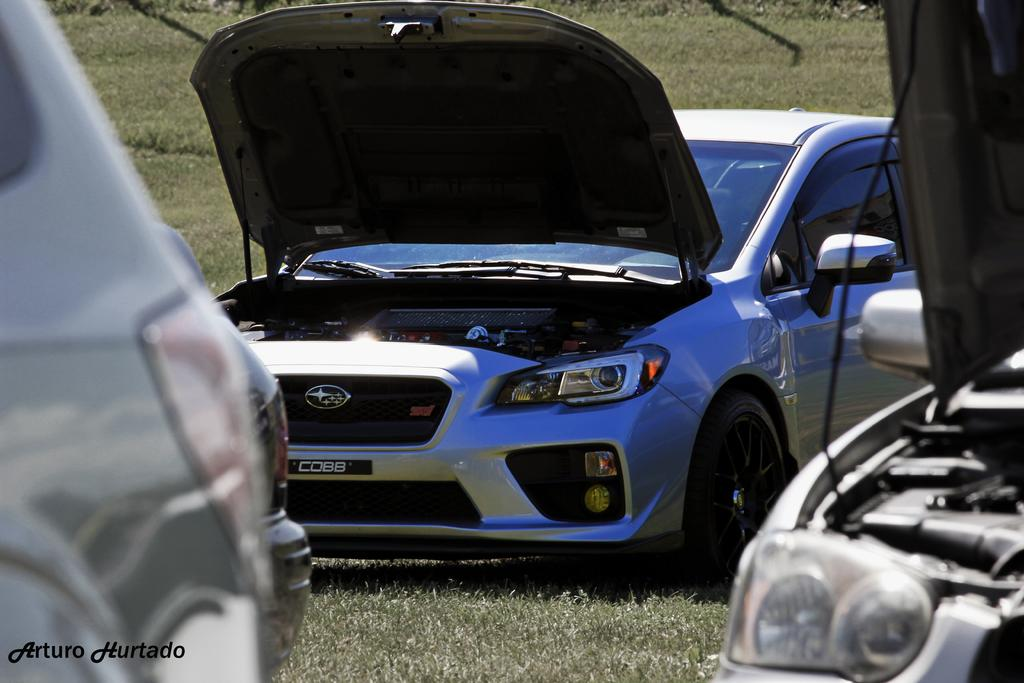What types of objects are present in the image? There are vehicles in the image. Where are the vehicles located? The vehicles are on the grass. What type of nut can be seen growing on the vehicles in the image? There are no nuts present in the image, and the vehicles are not growing anything. 